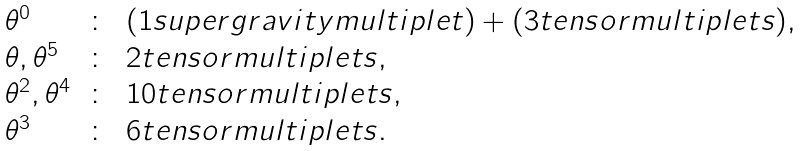Convert formula to latex. <formula><loc_0><loc_0><loc_500><loc_500>\begin{array} { l c l } \theta ^ { 0 } & \colon & ( 1 s u p e r g r a v i t y m u l t i p l e t ) + ( 3 t e n s o r m u l t i p l e t s ) , \\ \theta , \theta ^ { 5 } & \colon & 2 t e n s o r m u l t i p l e t s , \\ \theta ^ { 2 } , \theta ^ { 4 } & \colon & 1 0 t e n s o r m u l t i p l e t s , \\ \theta ^ { 3 } & \colon & 6 t e n s o r m u l t i p l e t s . \end{array}</formula> 